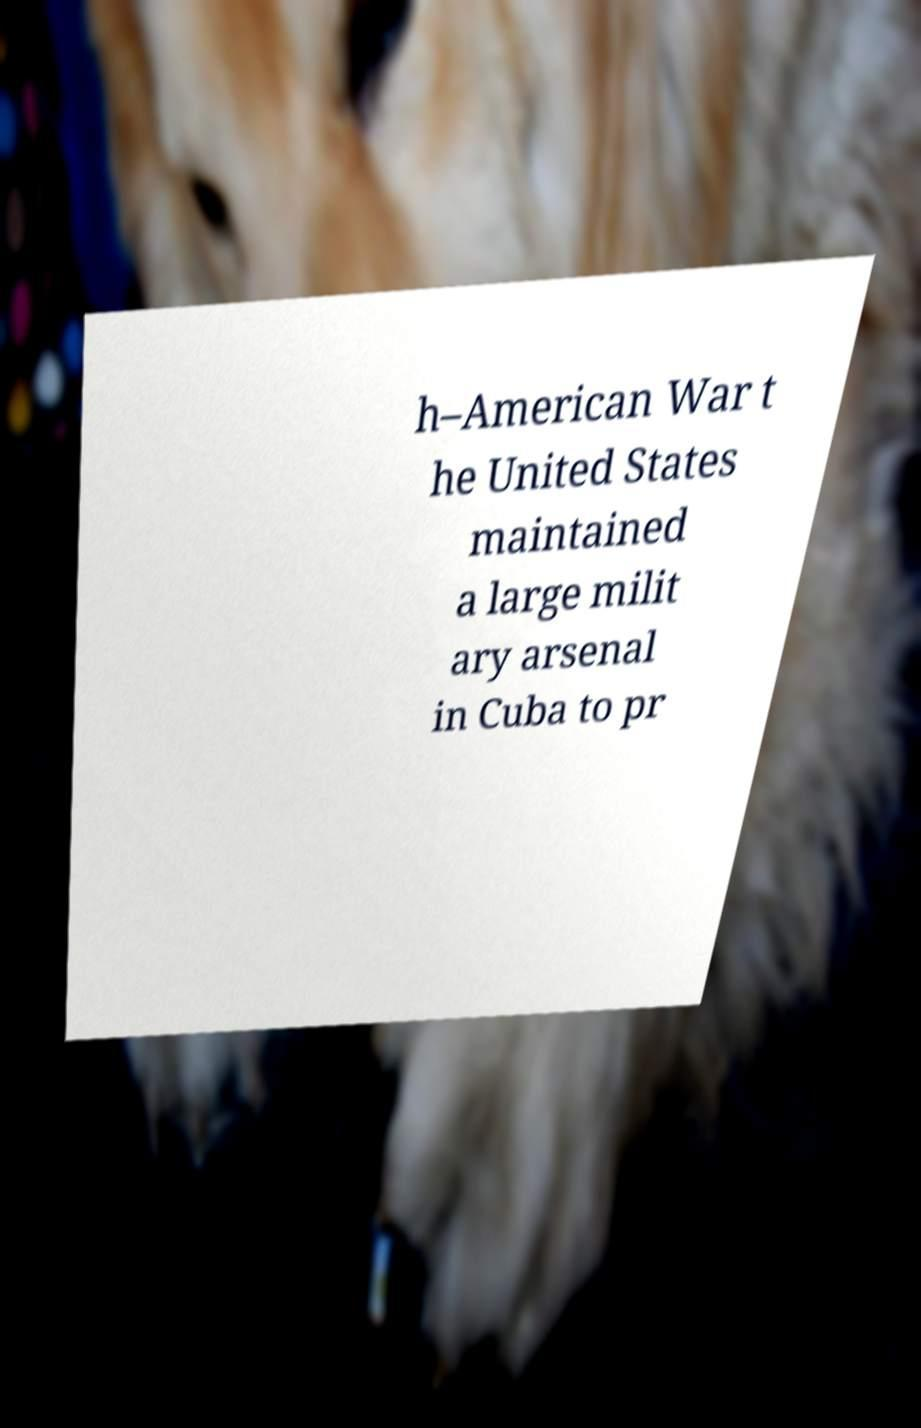There's text embedded in this image that I need extracted. Can you transcribe it verbatim? h–American War t he United States maintained a large milit ary arsenal in Cuba to pr 